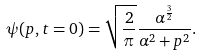Convert formula to latex. <formula><loc_0><loc_0><loc_500><loc_500>\psi ( p , t = 0 ) = \sqrt { \frac { 2 } { \pi } } \frac { \alpha ^ { \frac { 3 } { 2 } } } { \alpha ^ { 2 } + p ^ { 2 } } .</formula> 